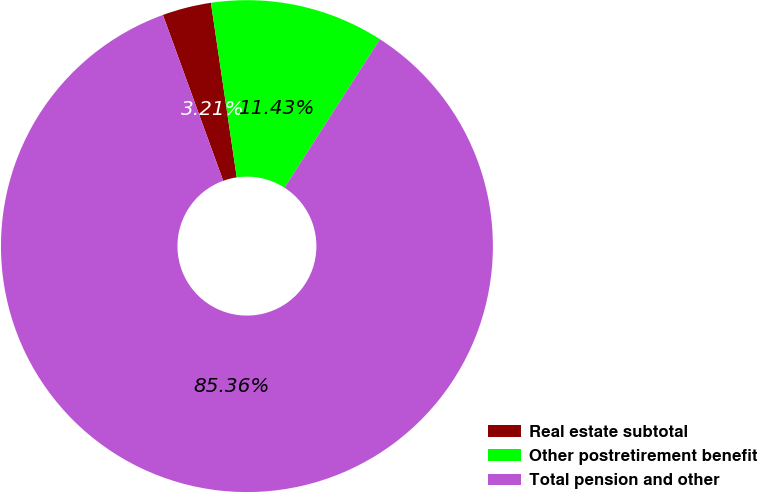Convert chart to OTSL. <chart><loc_0><loc_0><loc_500><loc_500><pie_chart><fcel>Real estate subtotal<fcel>Other postretirement benefit<fcel>Total pension and other<nl><fcel>3.21%<fcel>11.43%<fcel>85.36%<nl></chart> 